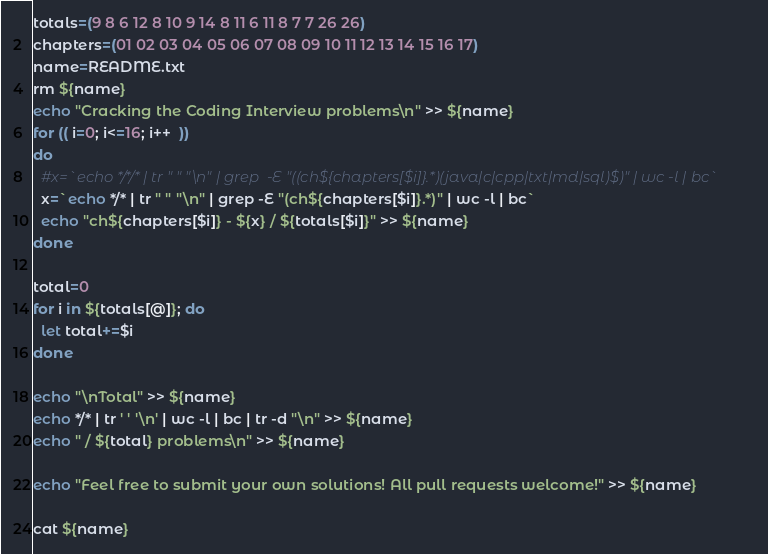Convert code to text. <code><loc_0><loc_0><loc_500><loc_500><_Bash_>totals=(9 8 6 12 8 10 9 14 8 11 6 11 8 7 7 26 26)
chapters=(01 02 03 04 05 06 07 08 09 10 11 12 13 14 15 16 17)
name=README.txt
rm ${name}
echo "Cracking the Coding Interview problems\n" >> ${name}
for (( i=0; i<=16; i++  ))
do
  #x=`echo */*/* | tr " " "\n" | grep  -E "((ch${chapters[$i]}.*)(java|c|cpp|txt|md|sql)$)" | wc -l | bc`
  x=`echo */* | tr " " "\n" | grep -E "(ch${chapters[$i]}.*)" | wc -l | bc`
  echo "ch${chapters[$i]} - ${x} / ${totals[$i]}" >> ${name}
done

total=0
for i in ${totals[@]}; do
  let total+=$i
done

echo "\nTotal" >> ${name}
echo */* | tr ' ' '\n' | wc -l | bc | tr -d "\n" >> ${name}
echo " / ${total} problems\n" >> ${name}

echo "Feel free to submit your own solutions! All pull requests welcome!" >> ${name}

cat ${name}
</code> 